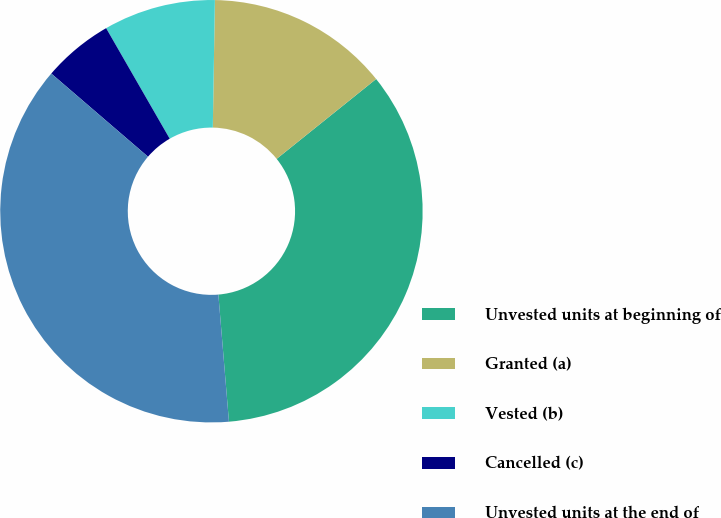Convert chart. <chart><loc_0><loc_0><loc_500><loc_500><pie_chart><fcel>Unvested units at beginning of<fcel>Granted (a)<fcel>Vested (b)<fcel>Cancelled (c)<fcel>Unvested units at the end of<nl><fcel>34.44%<fcel>13.97%<fcel>8.57%<fcel>5.39%<fcel>37.62%<nl></chart> 